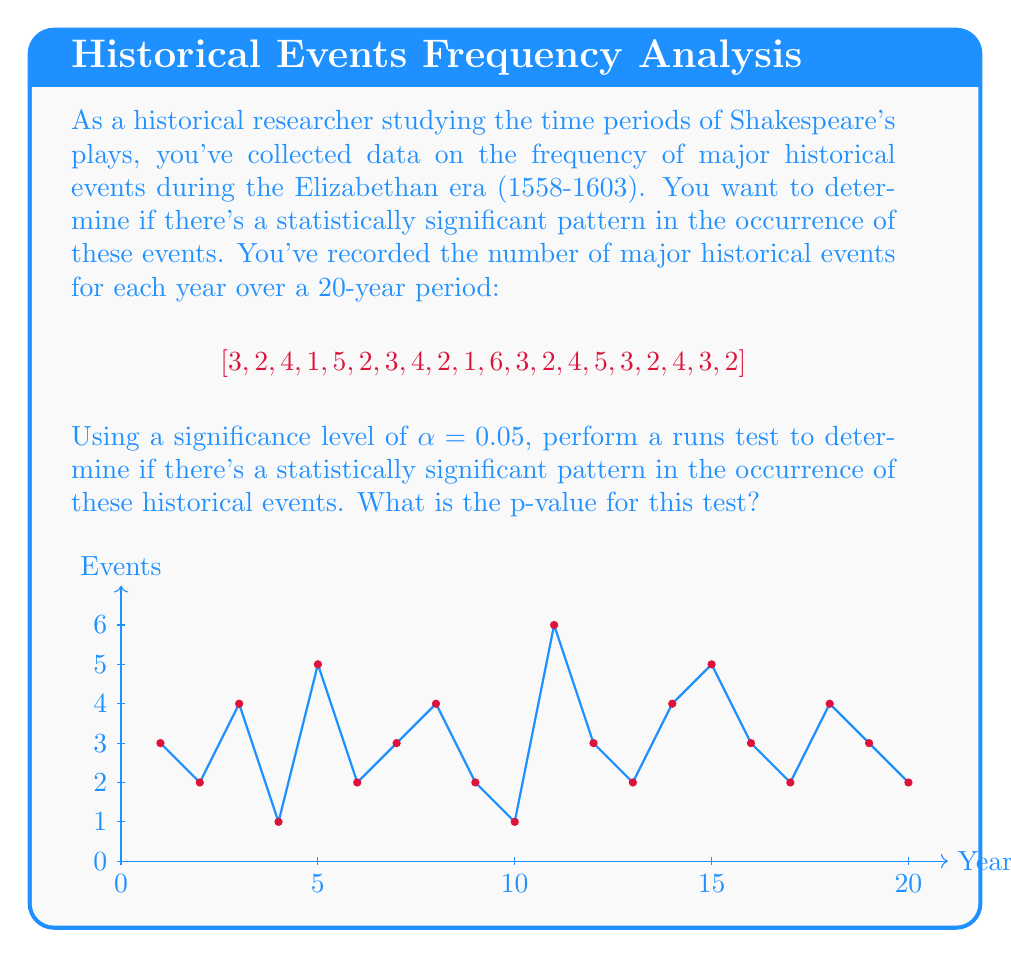Teach me how to tackle this problem. To perform a runs test and calculate the p-value, we'll follow these steps:

1) Calculate the median of the data:
   Sorted data: [1,1,2,2,2,2,2,3,3,3,3,3,4,4,4,4,5,5,6]
   Median = 3

2) Convert the data into a binary sequence based on whether each value is above or below the median:
   [0,0,1,0,1,0,0,1,0,0,1,0,0,1,1,0,0,1,0,0]

3) Count the number of runs (R):
   R = 10

4) Count the number of values above (n₁) and below or equal to (n₂) the median:
   n₁ = 8 (values > 3)
   n₂ = 12 (values ≤ 3)

5) Calculate the expected number of runs (μᵣ) and its standard deviation (σᵣ):
   $$μᵣ = \frac{2n₁n₂}{n₁ + n₂} + 1 = \frac{2(8)(12)}{20} + 1 = 10.6$$
   $$σᵣ = \sqrt{\frac{2n₁n₂(2n₁n₂ - n₁ - n₂)}{(n₁ + n₂)²(n₁ + n₂ - 1)}}$$
   $$= \sqrt{\frac{2(8)(12)(2(8)(12) - 8 - 12)}{20²(20 - 1)}} = 1.4491$$

6) Calculate the z-score:
   $$z = \frac{R - μᵣ}{σᵣ} = \frac{10 - 10.6}{1.4491} = -0.4140$$

7) Calculate the p-value (two-tailed test):
   p-value = 2 * P(Z < -0.4140) = 2 * 0.3394 = 0.6788

The p-value (0.6788) is greater than the significance level (0.05), so we fail to reject the null hypothesis. There is not enough evidence to conclude that there's a statistically significant pattern in the occurrence of these historical events.
Answer: p-value ≈ 0.6788 